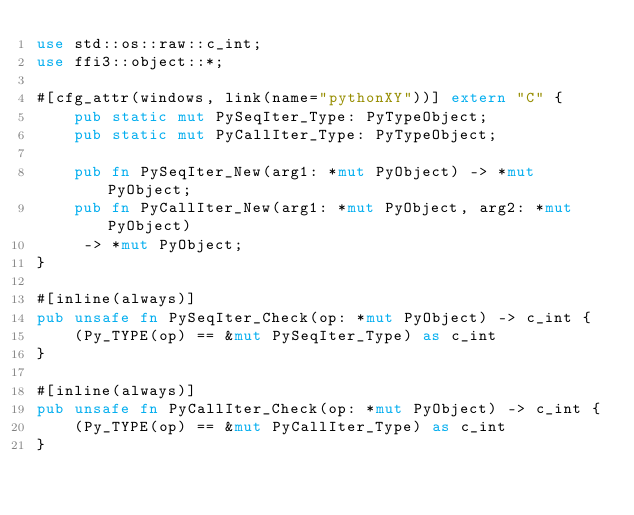Convert code to text. <code><loc_0><loc_0><loc_500><loc_500><_Rust_>use std::os::raw::c_int;
use ffi3::object::*;

#[cfg_attr(windows, link(name="pythonXY"))] extern "C" {
    pub static mut PySeqIter_Type: PyTypeObject;
    pub static mut PyCallIter_Type: PyTypeObject;

    pub fn PySeqIter_New(arg1: *mut PyObject) -> *mut PyObject;
    pub fn PyCallIter_New(arg1: *mut PyObject, arg2: *mut PyObject)
     -> *mut PyObject;
}

#[inline(always)]
pub unsafe fn PySeqIter_Check(op: *mut PyObject) -> c_int {
    (Py_TYPE(op) == &mut PySeqIter_Type) as c_int
}

#[inline(always)]
pub unsafe fn PyCallIter_Check(op: *mut PyObject) -> c_int {
    (Py_TYPE(op) == &mut PyCallIter_Type) as c_int
}


</code> 